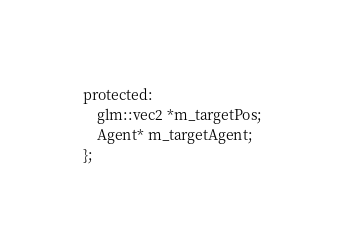<code> <loc_0><loc_0><loc_500><loc_500><_C_>protected:
	glm::vec2 *m_targetPos;
	Agent* m_targetAgent;
};

</code> 